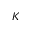Convert formula to latex. <formula><loc_0><loc_0><loc_500><loc_500>K</formula> 